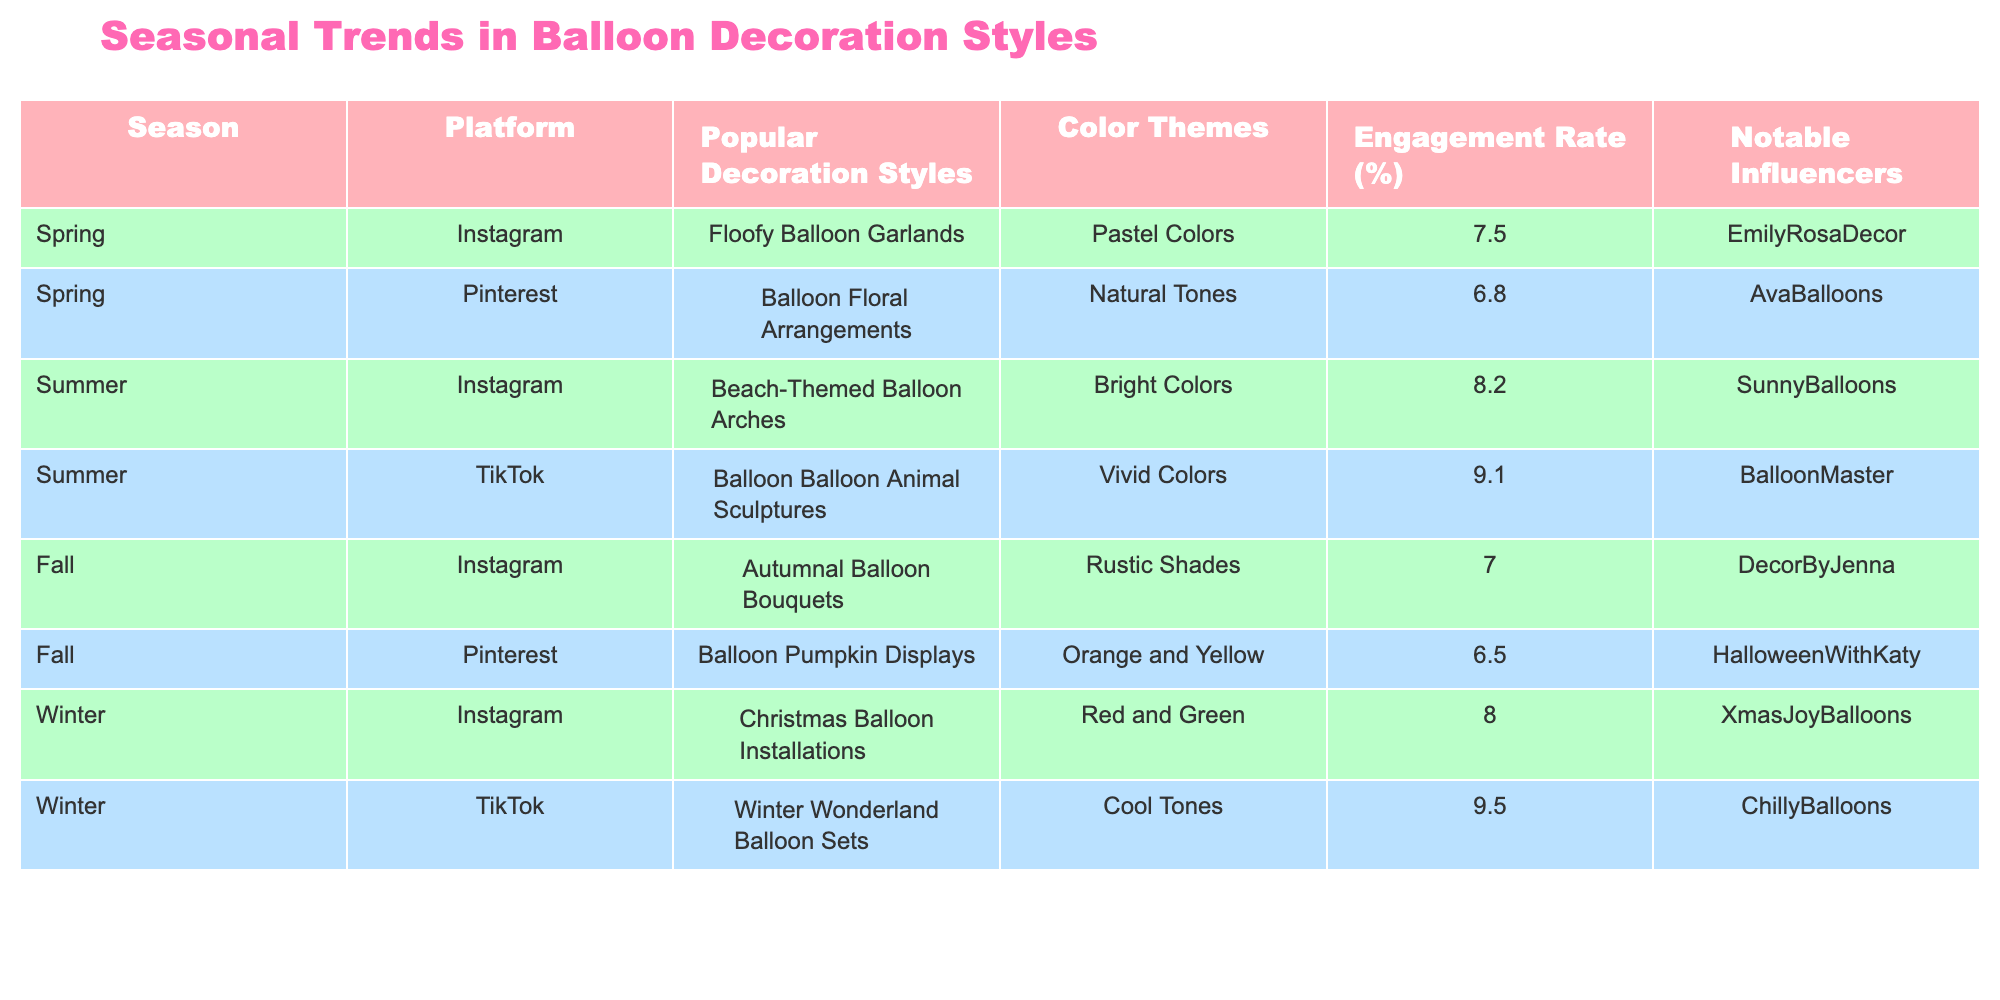What is the engagement rate for Summer decorations on TikTok? From the table, the engagement rate for Summer decorations on TikTok is listed as 9.1%.
Answer: 9.1% Which platform had the lowest engagement rate in Fall? By looking at the Fall section in the table, we can see that the engagement rate for Pinterest (6.5%) is lower than that of Instagram (7.0%). Thus, Pinterest had the lowest engagement rate in Fall.
Answer: Pinterest What is the average engagement rate across all seasons for Instagram? For Instagram, the engagement rates are: Spring (7.5%), Summer (8.2%), Fall (7.0%), and Winter (8.0%). Summing these gives 30.7. Dividing by the number of seasons (4) gives an average engagement rate of 30.7/4 = 7.675%.
Answer: 7.675% Is there an autumn decoration style that features Pumpkins? The table indicates that in Fall, Pinterest features "Balloon Pumpkin Displays," which confirms the presence of a Pumpkin theme in autumn decorations.
Answer: Yes What color theme is associated with Winter decorations on Instagram? Referring to the table under the Winter section for Instagram, the associated color theme is "Red and Green" for the Christmas Balloon Installations.
Answer: Red and Green Which decoration style on TikTok had the highest engagement rate, and what was it? By examining the TikTok entries in the table, the Winter decoration style "Winter Wonderland Balloon Sets" has the highest engagement rate at 9.5%. Therefore, it had the highest engagement rate among TikTok decorations.
Answer: Winter Wonderland Balloon Sets, 9.5% What is the difference in engagement rate between Summer decorations on Instagram and Winter decorations on TikTok? Looking at the engagement rates for Summer on Instagram (8.2%) and Winter on TikTok (9.5%), we find the difference as follows: 9.5% - 8.2% = 1.3%.
Answer: 1.3% Which season features decorations with Natural tones? The Spring section of the table indicates that Pinterest features "Balloon Floral Arrangements" with Natural tones. Thus, Spring is the season for such decorations.
Answer: Spring 